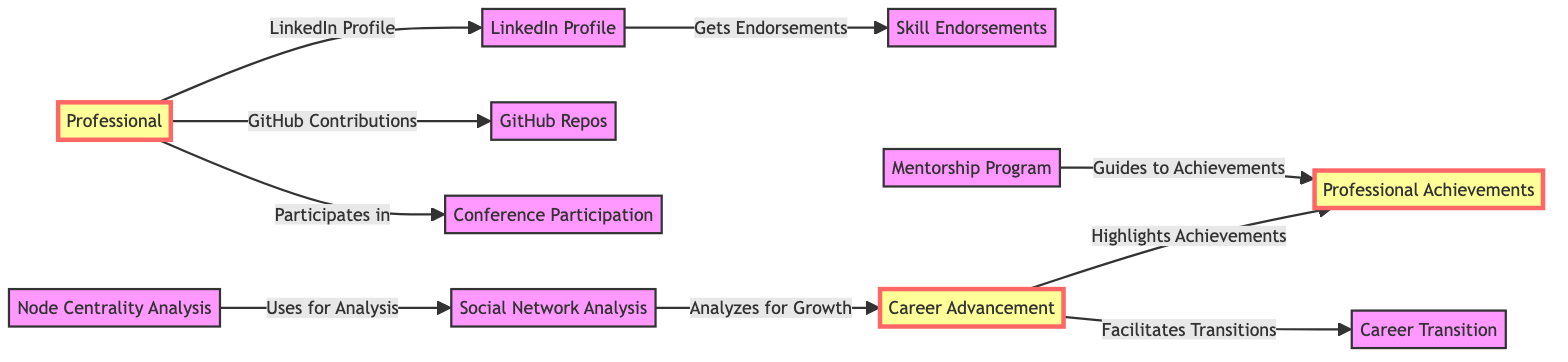What's the main subject of the diagram? The diagram focuses on the impact of professional networks on career advancement using social network analysis and node centrality measures.
Answer: Professional Networks How many nodes are there in the diagram? By counting the individual elements represented, there are a total of 10 nodes in the diagram.
Answer: 10 What does the Individual node connect to? The Individual node connects to LinkedIn Profile, GitHub Repos, and Conference Participation, indicating various ways professionals engage with their networks.
Answer: LinkedIn Profile, GitHub Repos, Conference Participation Which node is associated with analyzing for growth? The node responsible for analyzing for growth is the Network Analysis node, as indicated by its direct connection to the Career Advancement node.
Answer: Network Analysis What relationship is represented between Mentorship and Professional Achievements? The diagram indicates that Mentorship guides individuals to their Professional Achievements, showing the support role of mentorship in career success.
Answer: Guides to Achievements How does Career Advancement relate to Professional Achievements? Career Advancement highlights achievements, meaning it emphasizes or brings attention to an individual's Professional Achievements.
Answer: Highlights Achievements What does Node Centrality Analysis utilize for its analysis? Node Centrality Analysis uses Social Network Analysis for its analytical processes, showing the importance of networks in understanding career dynamics.
Answer: Uses for Analysis Which node facilitates Career Transition? The Career Advancement node also facilitates Career Transition, showing its dual role in both promoting achievements and assisting in shifts in career paths.
Answer: Facilitates Transitions What node provides skill endorsements? The node that provides skill endorsements is the Endorsements node, which is linked to the LinkedIn Profile.
Answer: Skill Endorsements 